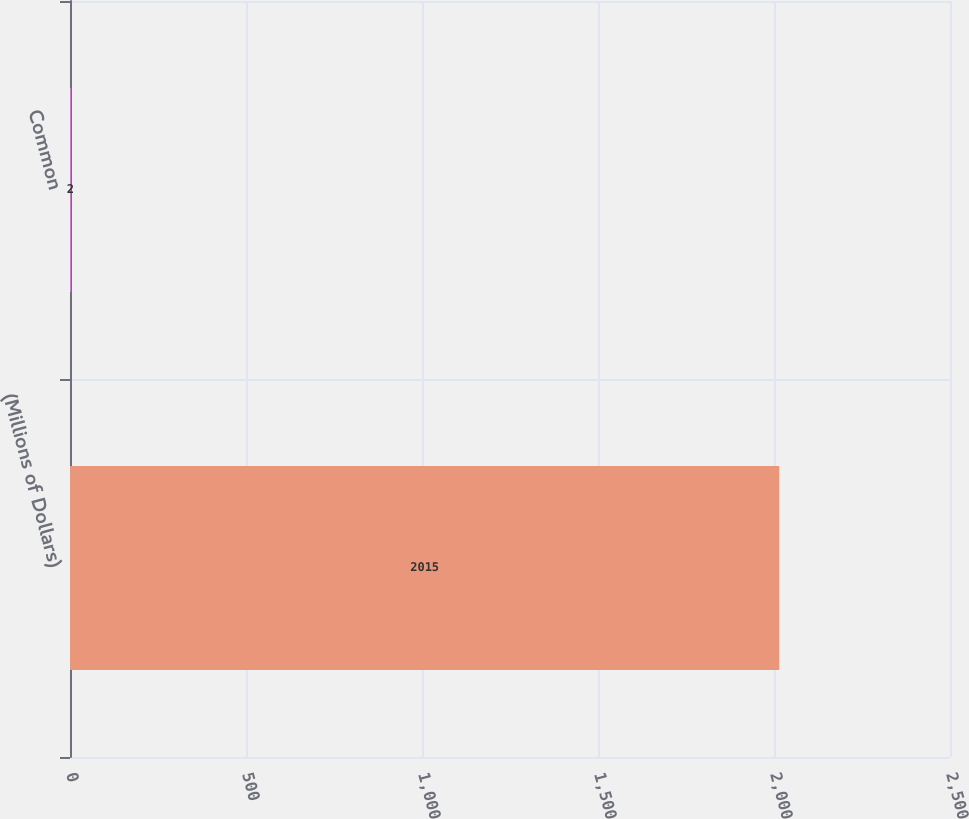Convert chart. <chart><loc_0><loc_0><loc_500><loc_500><bar_chart><fcel>(Millions of Dollars)<fcel>Common<nl><fcel>2015<fcel>2<nl></chart> 